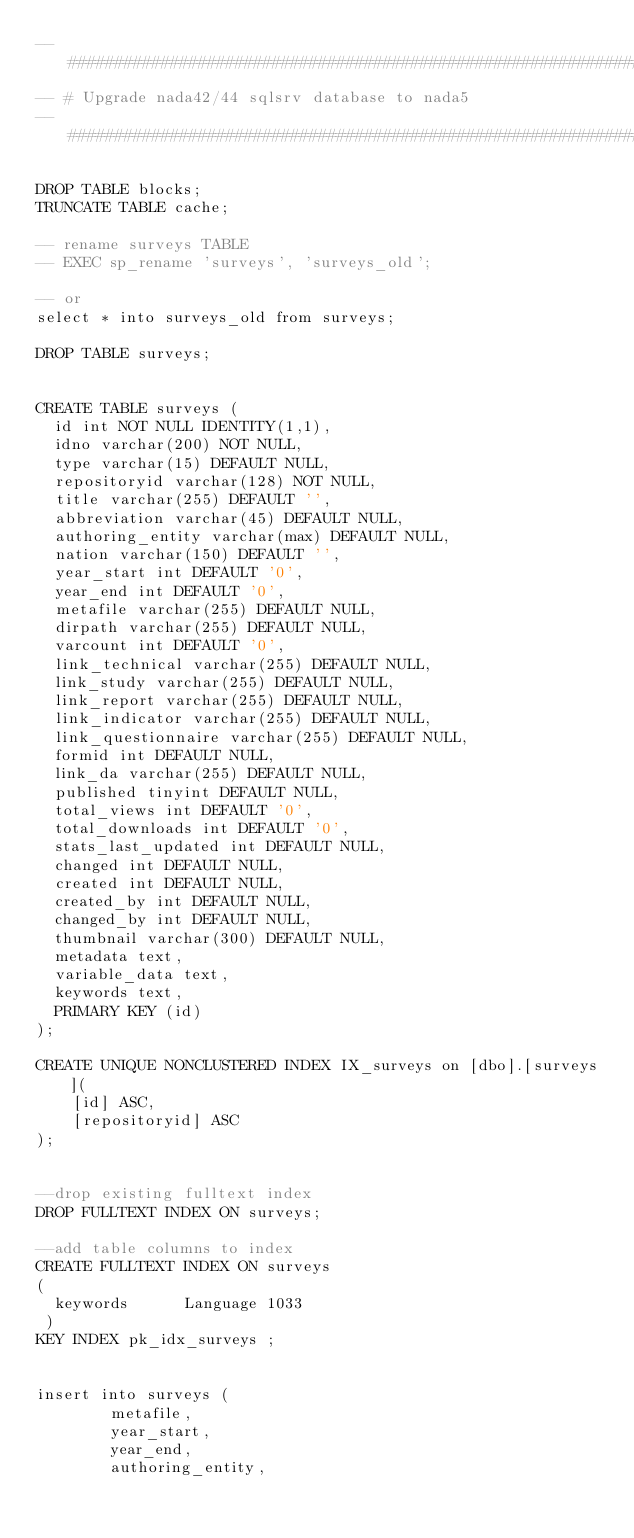Convert code to text. <code><loc_0><loc_0><loc_500><loc_500><_SQL_>-- ###################################################################################
-- # Upgrade nada42/44 sqlsrv database to nada5
-- ###################################################################################

DROP TABLE blocks;
TRUNCATE TABLE cache;

-- rename surveys TABLE
-- EXEC sp_rename 'surveys', 'surveys_old';  

-- or
select * into surveys_old from surveys;

DROP TABLE surveys;


CREATE TABLE surveys (
  id int NOT NULL IDENTITY(1,1),
  idno varchar(200) NOT NULL,
  type varchar(15) DEFAULT NULL,
  repositoryid varchar(128) NOT NULL,
  title varchar(255) DEFAULT '',
  abbreviation varchar(45) DEFAULT NULL,
  authoring_entity varchar(max) DEFAULT NULL,
  nation varchar(150) DEFAULT '',
  year_start int DEFAULT '0',
  year_end int DEFAULT '0',
  metafile varchar(255) DEFAULT NULL,
  dirpath varchar(255) DEFAULT NULL,
  varcount int DEFAULT '0',
  link_technical varchar(255) DEFAULT NULL,
  link_study varchar(255) DEFAULT NULL,
  link_report varchar(255) DEFAULT NULL,
  link_indicator varchar(255) DEFAULT NULL,
  link_questionnaire varchar(255) DEFAULT NULL,
  formid int DEFAULT NULL,
  link_da varchar(255) DEFAULT NULL,
  published tinyint DEFAULT NULL,  
  total_views int DEFAULT '0',
  total_downloads int DEFAULT '0',
  stats_last_updated int DEFAULT NULL,
  changed int DEFAULT NULL,
  created int DEFAULT NULL,
  created_by int DEFAULT NULL,
  changed_by int DEFAULT NULL,
  thumbnail varchar(300) DEFAULT NULL,
  metadata text,
  variable_data text,
  keywords text,  
  PRIMARY KEY (id)
);

CREATE UNIQUE NONCLUSTERED INDEX IX_surveys on [dbo].[surveys](
	[id] ASC,
	[repositoryid] ASC
);


--drop existing fulltext index
DROP FULLTEXT INDEX ON surveys;

--add table columns to index
CREATE FULLTEXT INDEX ON surveys
( 
  keywords		Language 1033
 ) 
KEY INDEX pk_idx_surveys ; 


insert into surveys (
        metafile,
        year_start,
        year_end,
        authoring_entity,</code> 